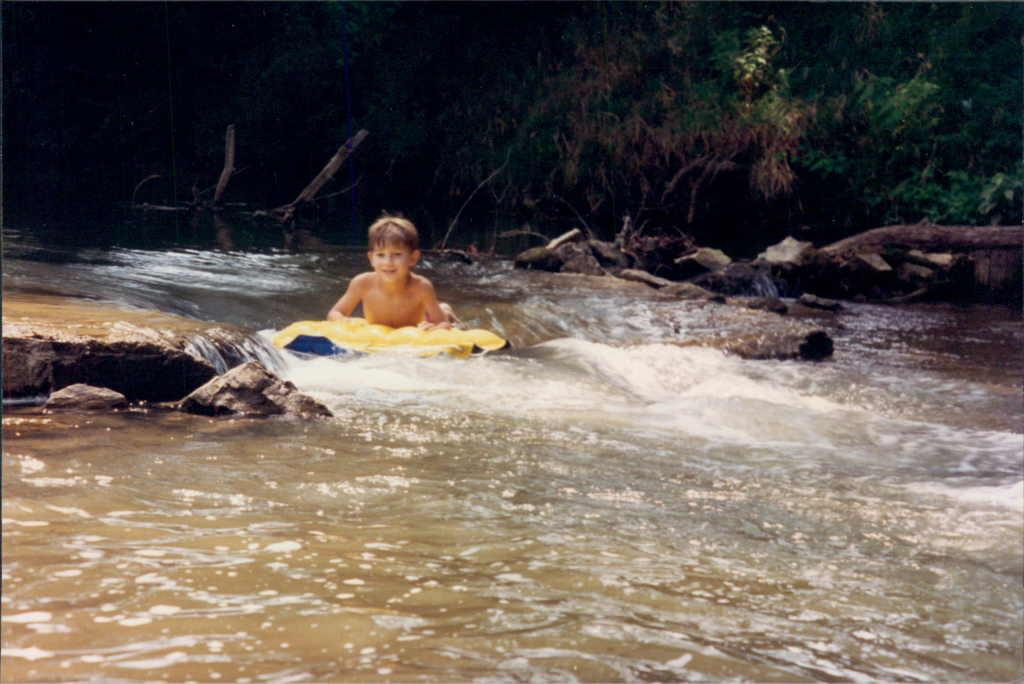Who is in the image? There is a boy in the image. What is the boy doing in the image? The boy is on an object on the water. What can be seen in the background of the image? There are stones, logs, and trees in the background of the image. What type of wren can be seen perched on the boy's leg in the image? There is no wren present in the image, and the boy's leg is not visible. 